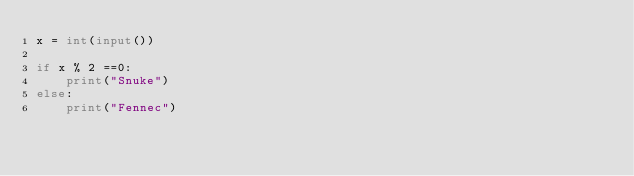Convert code to text. <code><loc_0><loc_0><loc_500><loc_500><_Python_>x = int(input())

if x % 2 ==0:
    print("Snuke")
else:
    print("Fennec")</code> 